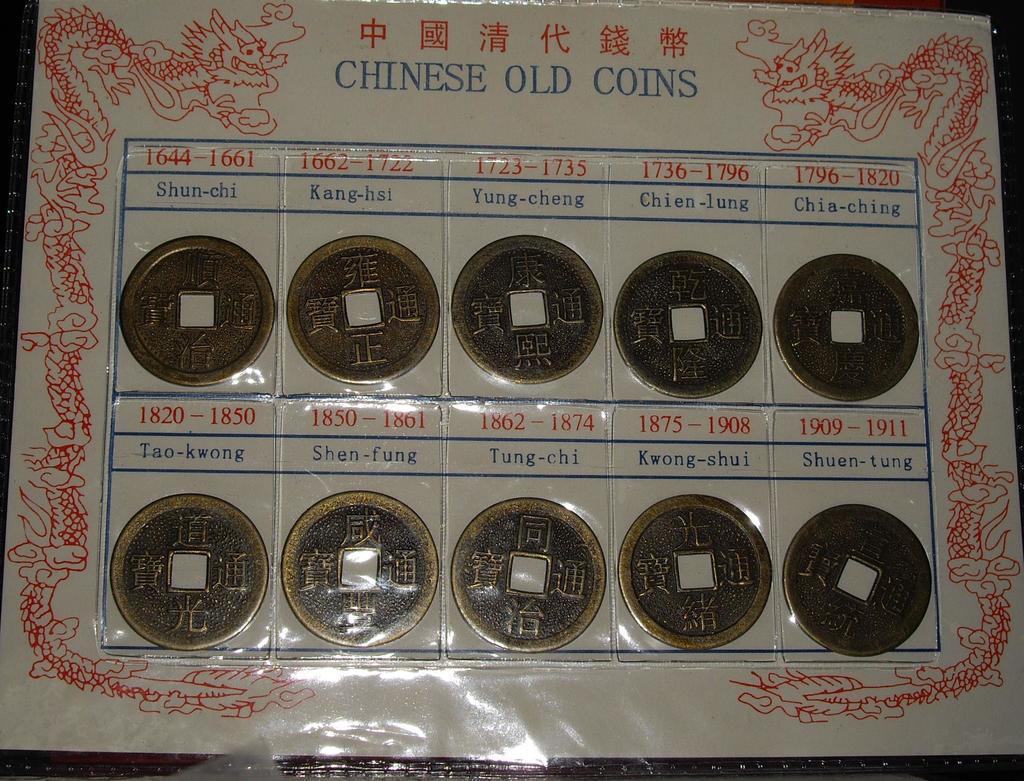<image>
Provide a brief description of the given image. A collection of old Chinese coins in a plastic display with each coin year and location labeled. 